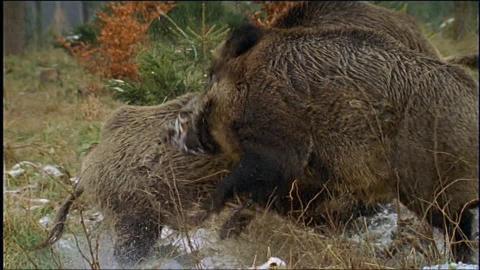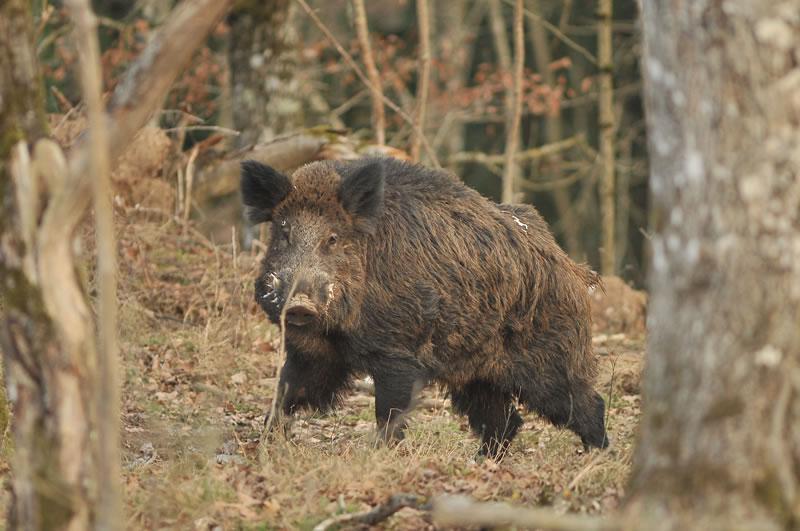The first image is the image on the left, the second image is the image on the right. Evaluate the accuracy of this statement regarding the images: "there is one hog on the right image standing". Is it true? Answer yes or no. Yes. 